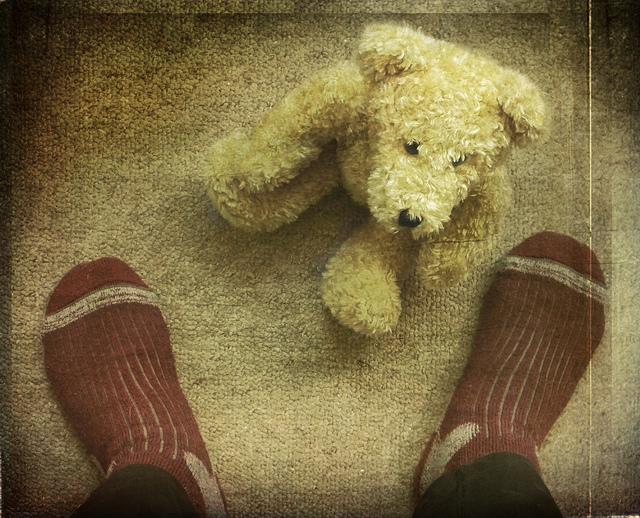What is the person wearing on their feet?
Write a very short answer. Socks. How many bears are there?
Be succinct. 1. Is the bear alive?
Quick response, please. No. Did a human feed these animals?
Quick response, please. No. 